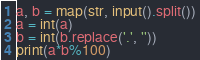<code> <loc_0><loc_0><loc_500><loc_500><_Python_>a, b = map(str, input().split())
a = int(a)
b = int(b.replace('.', ''))
print(a*b%100)</code> 